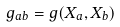Convert formula to latex. <formula><loc_0><loc_0><loc_500><loc_500>g _ { a b } = g ( X _ { a } , X _ { b } )</formula> 